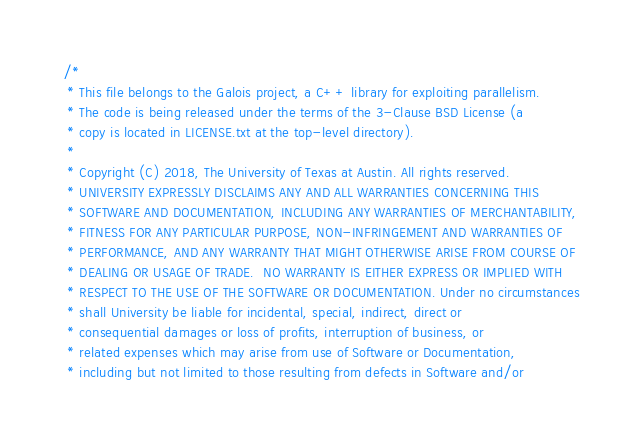<code> <loc_0><loc_0><loc_500><loc_500><_C_>/*
 * This file belongs to the Galois project, a C++ library for exploiting parallelism.
 * The code is being released under the terms of the 3-Clause BSD License (a
 * copy is located in LICENSE.txt at the top-level directory).
 *
 * Copyright (C) 2018, The University of Texas at Austin. All rights reserved.
 * UNIVERSITY EXPRESSLY DISCLAIMS ANY AND ALL WARRANTIES CONCERNING THIS
 * SOFTWARE AND DOCUMENTATION, INCLUDING ANY WARRANTIES OF MERCHANTABILITY,
 * FITNESS FOR ANY PARTICULAR PURPOSE, NON-INFRINGEMENT AND WARRANTIES OF
 * PERFORMANCE, AND ANY WARRANTY THAT MIGHT OTHERWISE ARISE FROM COURSE OF
 * DEALING OR USAGE OF TRADE.  NO WARRANTY IS EITHER EXPRESS OR IMPLIED WITH
 * RESPECT TO THE USE OF THE SOFTWARE OR DOCUMENTATION. Under no circumstances
 * shall University be liable for incidental, special, indirect, direct or
 * consequential damages or loss of profits, interruption of business, or
 * related expenses which may arise from use of Software or Documentation,
 * including but not limited to those resulting from defects in Software and/or</code> 